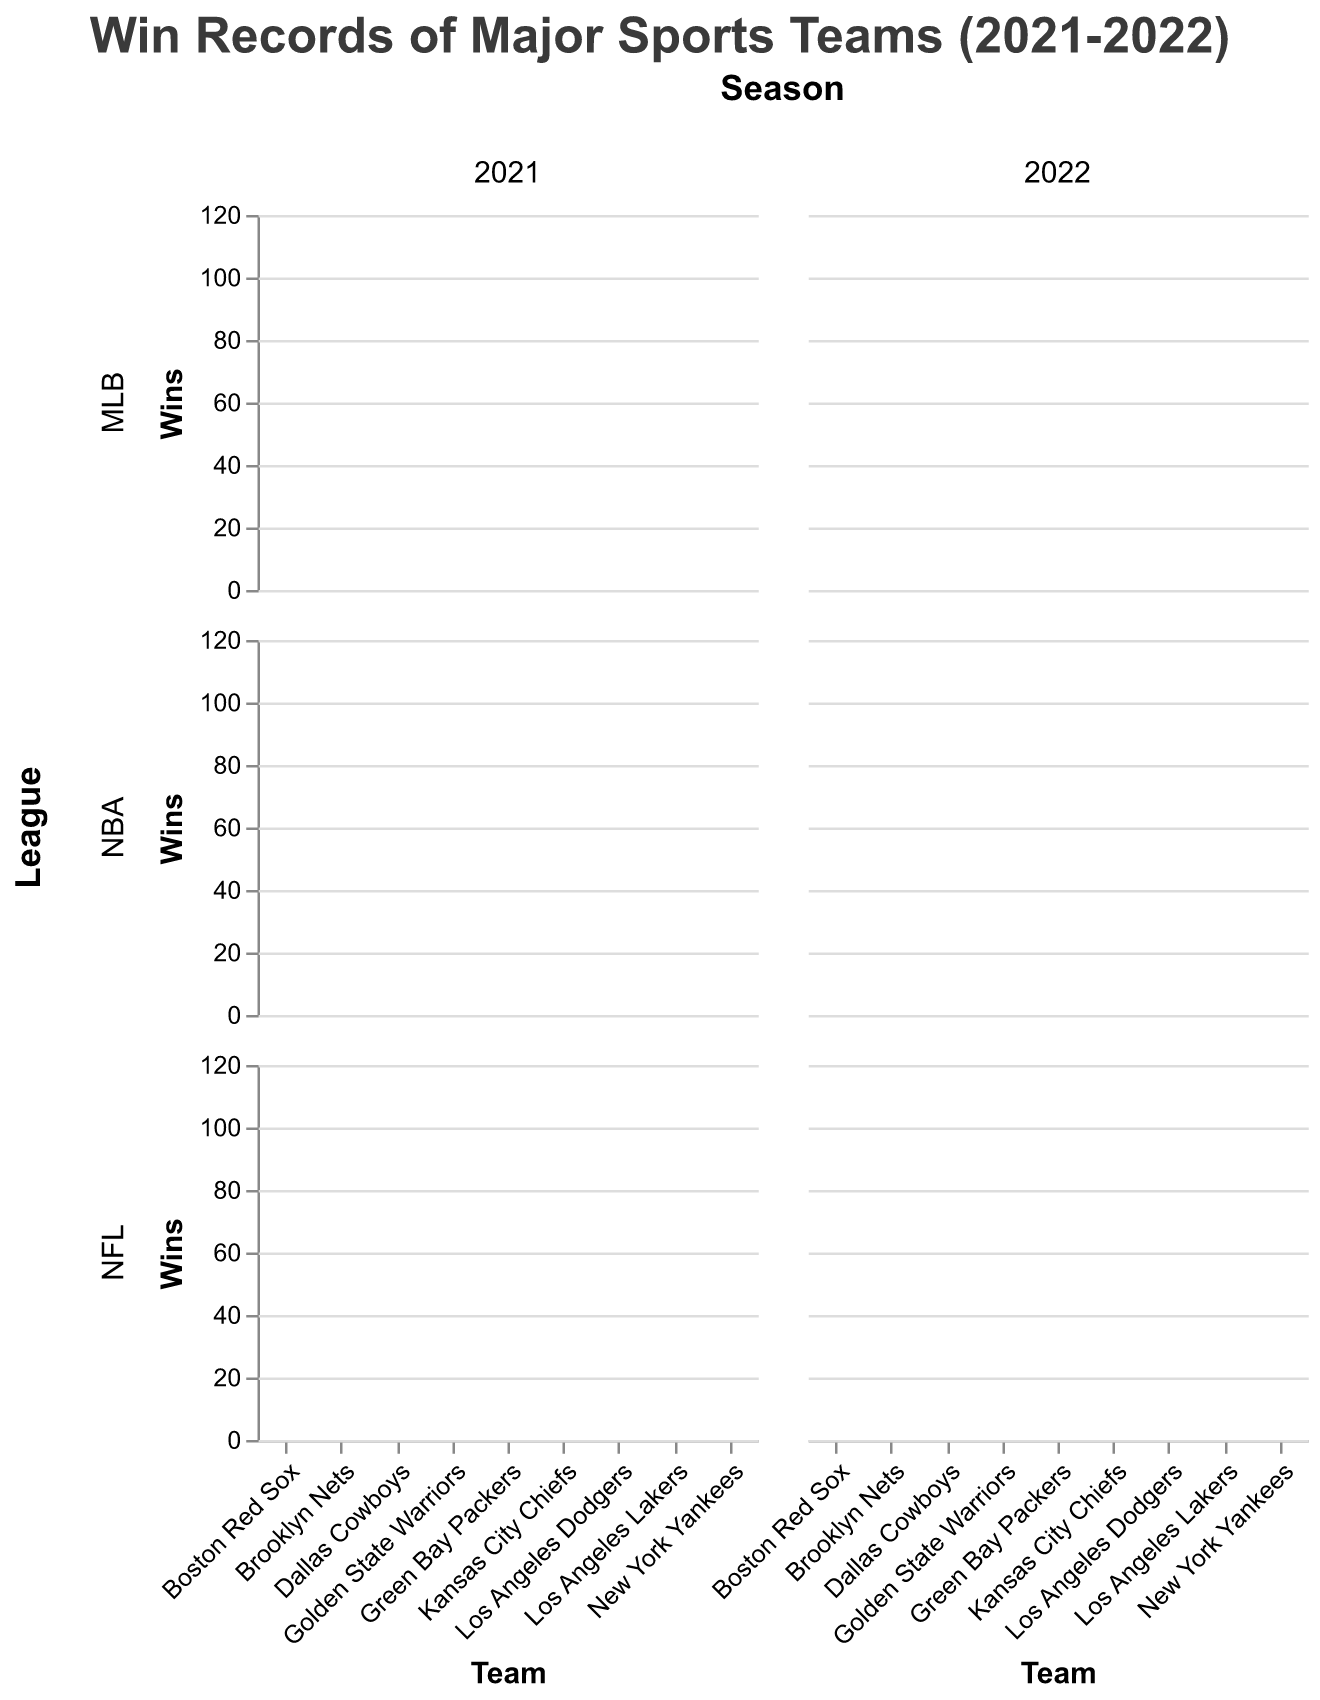Which team had the highest number of wins in the 2021 season? First, identify the 2021 season. Then, compare the total wins of all teams across different leagues. The Los Angeles Dodgers in MLB had the highest number of wins with 106.
Answer: Los Angeles Dodgers How did the New York Yankees perform in terms of wins in 2021 compared to 2022? For both seasons, find the wins for the New York Yankees. In 2021, they had 92 wins, and in 2022, they had 99 wins.
Answer: They won more in 2022 Which team had the smallest difference in wins between 2021 and 2022? Calculate the difference in wins for each team between 2021 and 2022. The Green Bay Packers had a consistent performance with 13 wins in both years, making the difference 0.
Answer: Green Bay Packers In the 2021 and 2022 seasons, which NBA team showed the most significant improvement in wins? Calculate the change in wins for each NBA team from 2021 to 2022. The Brooklyn Nets improved by 2 wins, Golden State Warriors improved by 2 wins, and the Los Angeles Lakers improved by 1 win. Therefore, multiple teams improved, but all by 2 wins.
Answer: Golden State Warriors and Brooklyn Nets In the MLB league, which team had the largest increase in losses from 2021 to 2022? Look at the loss data for MLB teams for 2021 and 2022 and calculate the difference. The Boston Red Sox went from 70 losses in 2021 to 84 losses in 2022, an increase of 14 losses.
Answer: Boston Red Sox Which NFL team had the highest number of wins in the 2022 season? Identify the NFL section in the 2022 season and compare the wins. The Kansas City Chiefs had the highest number with 14 wins.
Answer: Kansas City Chiefs What was the combined total number of wins for the MLB teams in the 2022 season? Sum the number of wins for all MLB teams in the 2022 season: 99 (Yankees) + 78 (Red Sox) + 111 (Dodgers) = 288.
Answer: 288 How many teams had a higher number of wins in 2022 compared to 2021? Compare wins for all teams for both years. The Golden State Warriors, Brooklyn Nets, Kansas City Chiefs, Los Angeles Dodgers, and New York Yankees had more wins in 2022. Count them to get the total, which is 5 teams.
Answer: 5 teams Which league showed the overall most consistent win trend between 2021 and 2022, based on the teams' wins? Analyze the difference in wins for all teams across the leagues from 2021 to 2022. NFL teams had smaller or more consistent changes compared to some MLB and NBA teams.
Answer: NFL 